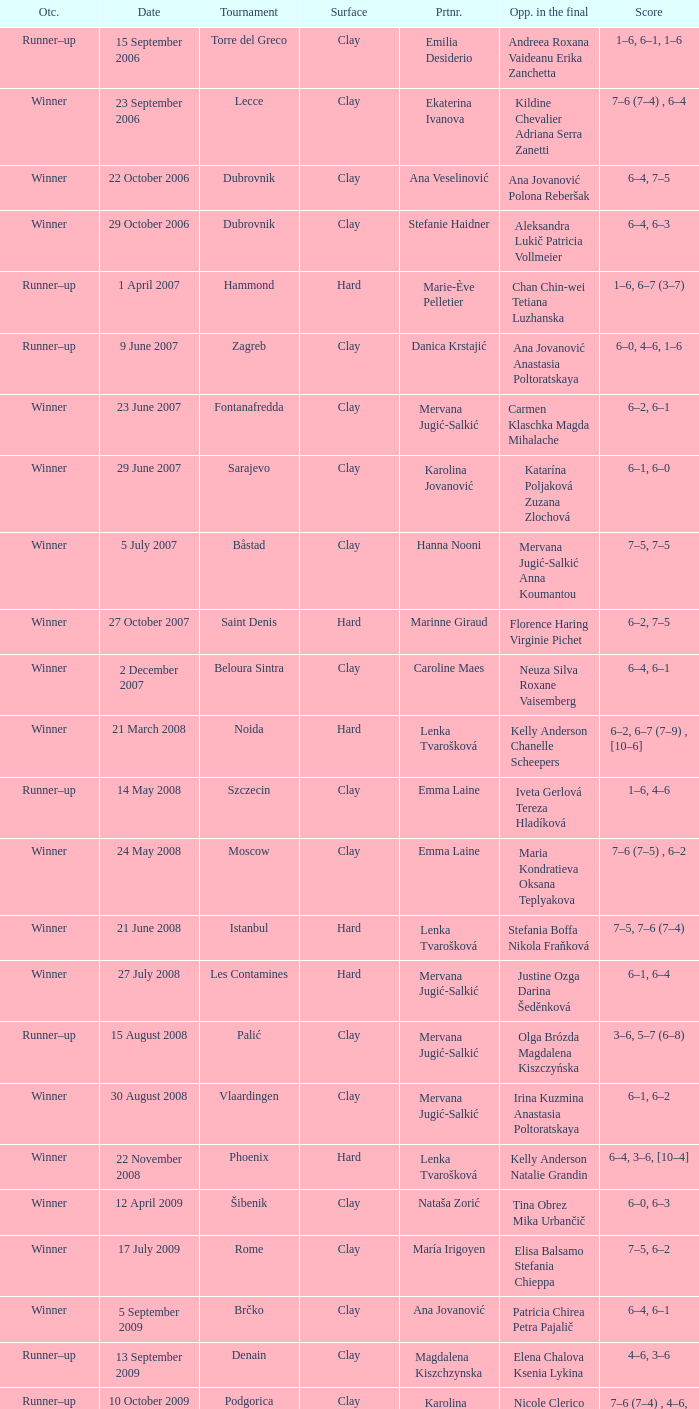Who were the opponents in the final at Noida? Kelly Anderson Chanelle Scheepers. 